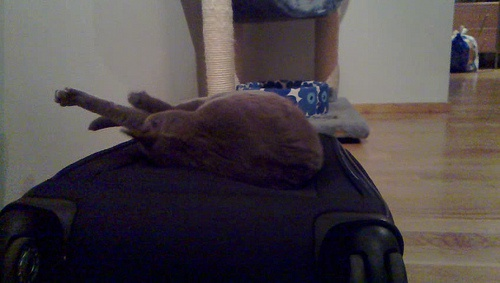Describe the objects in this image and their specific colors. I can see suitcase in gray, black, and navy tones and cat in gray, black, and purple tones in this image. 